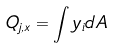Convert formula to latex. <formula><loc_0><loc_0><loc_500><loc_500>Q _ { j , x } = \int y _ { i } d A</formula> 